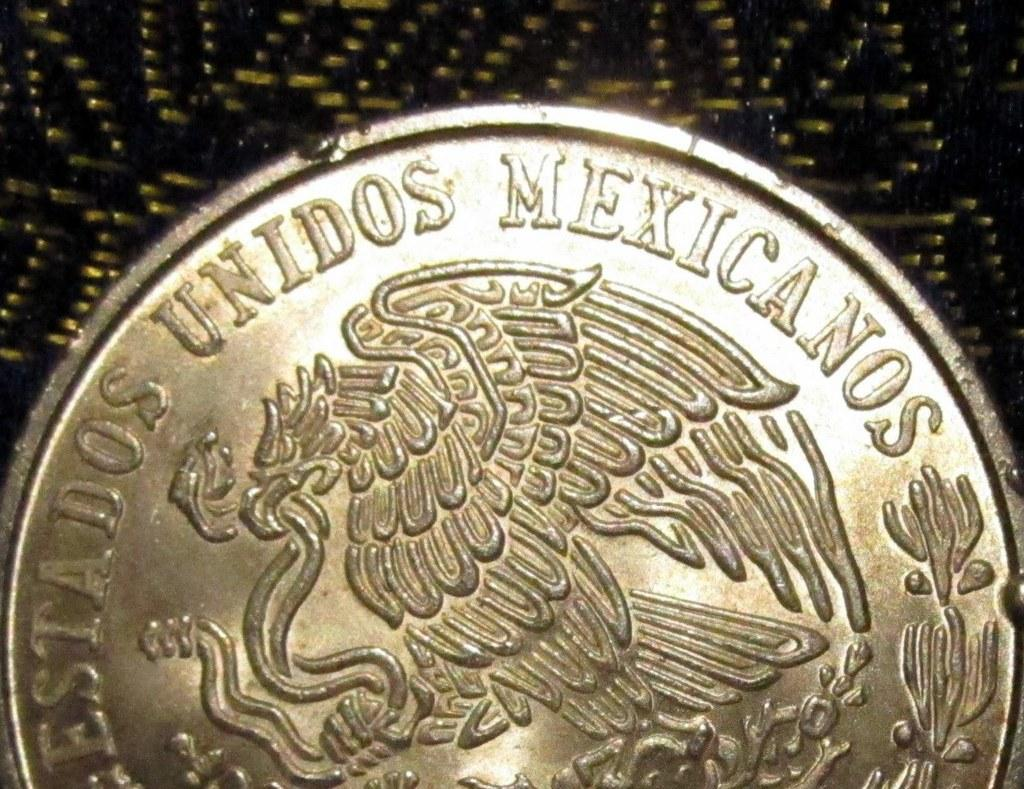<image>
Describe the image concisely. Estados Unidos Mexicanos is stamped around the edge of this coin. 